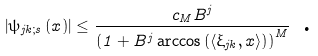Convert formula to latex. <formula><loc_0><loc_0><loc_500><loc_500>\left | \psi _ { j k ; s } \left ( x \right ) \right | \leq \frac { c _ { M } B ^ { j } } { \left ( 1 + B ^ { j } \arccos \left ( \langle \xi _ { j k } , x \rangle \right ) \right ) ^ { M } } \text { .}</formula> 